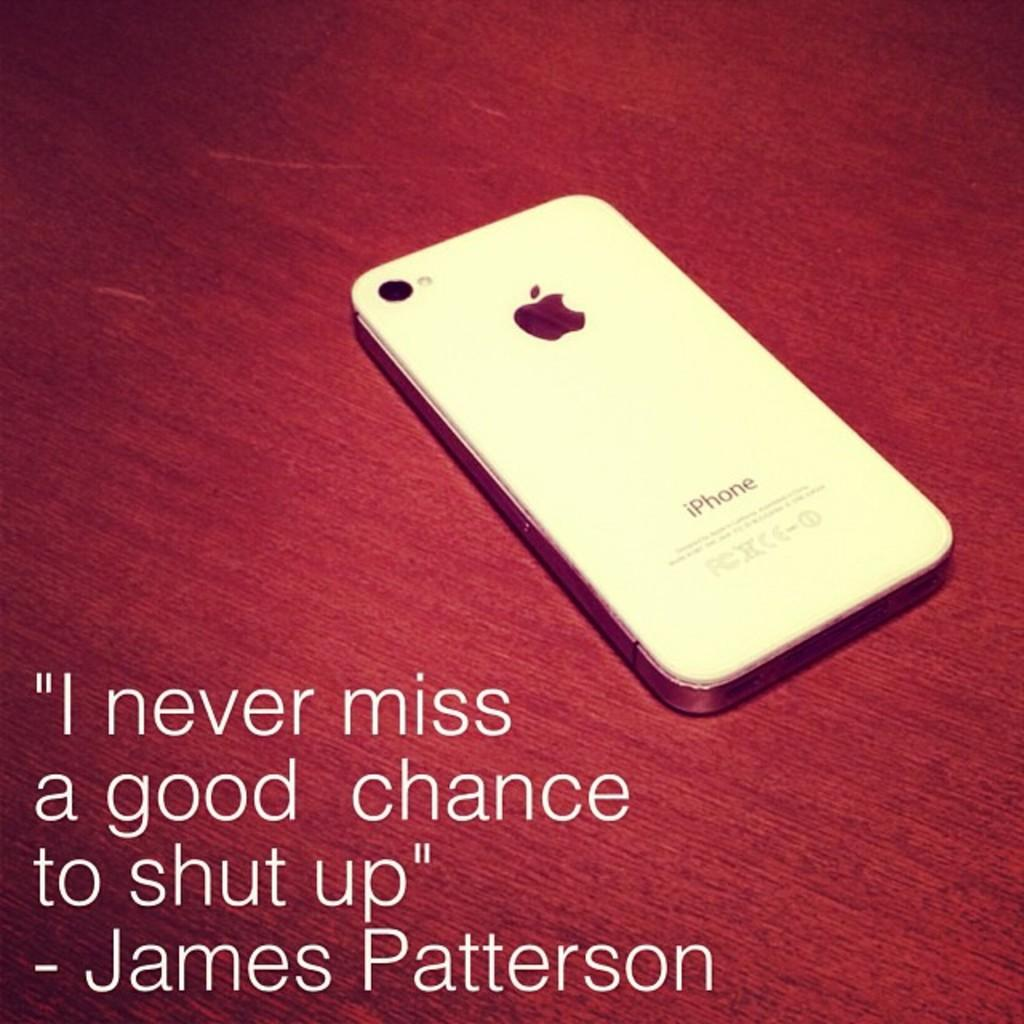<image>
Provide a brief description of the given image. The iphone is sitting on the table beside a quote from James Patterson. 